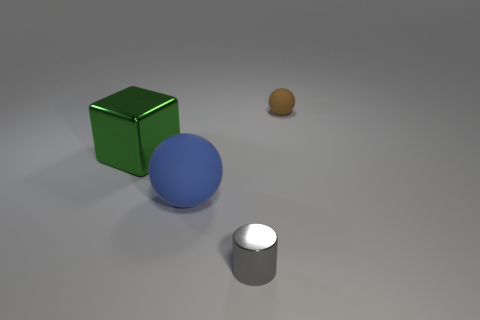Subtract all red cylinders. Subtract all blue cubes. How many cylinders are left? 1 Subtract all brown cubes. How many yellow cylinders are left? 0 Add 4 yellows. How many large objects exist? 0 Subtract all tiny green rubber objects. Subtract all small rubber things. How many objects are left? 3 Add 2 small metal cylinders. How many small metal cylinders are left? 3 Add 3 purple objects. How many purple objects exist? 3 Add 4 small metallic things. How many objects exist? 8 Subtract all blue spheres. How many spheres are left? 1 Subtract 0 cyan cylinders. How many objects are left? 4 Subtract all blocks. How many objects are left? 3 